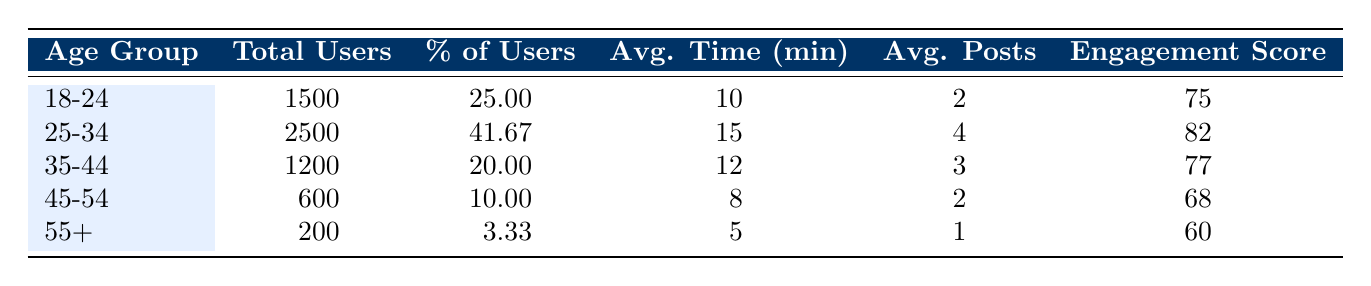What is the total number of users in the age group 25-34? Referring to the table, the total users in the age group 25-34 is directly listed as 2500.
Answer: 2500 What percentage of users belong to the age group 45-54? The table shows that the percentage of users in the age group 45-54 is 10.00%.
Answer: 10.00% Which age group has the highest average posts shared per user? By comparing the values in the "Avg. Posts" column, the age group 25-34 has the highest value at 4.
Answer: 25-34 What is the sum of the average time spent per visit for the age groups 35-44 and 45-54? Adding the average time for these age groups: 12 (for 35-44) + 8 (for 45-54) equals 20.
Answer: 20 Is the engagement score for the age group 55+ greater than that of the age group 18-24? The engagement score for the age group 55+ is 60, while for 18-24 it is 75. Therefore, it is false that 55+ is greater.
Answer: No What is the average engagement score across all age groups? To find the average engagement score, we sum the engagement scores (75 + 82 + 77 + 68 + 60) = 362, and divide by the number of age groups (5): 362/5 = 72.4.
Answer: 72.4 Which age group has the lowest average time spent per visit? The table indicates that the age group 55+ has the lowest average time spent per visit at 5 minutes.
Answer: 55+ What is the difference in total users between the age groups 25-34 and 35-44? The number of users in 25-34 is 2500 and in 35-44 is 1200. The difference is 2500 - 1200 = 1300.
Answer: 1300 Are users in the age group 18-24 more engaged than those in the age group 45-54? The engagement score for age group 18-24 is 75, while for 45-54 it is 68. Since 75 is greater than 68, the statement is true.
Answer: Yes 